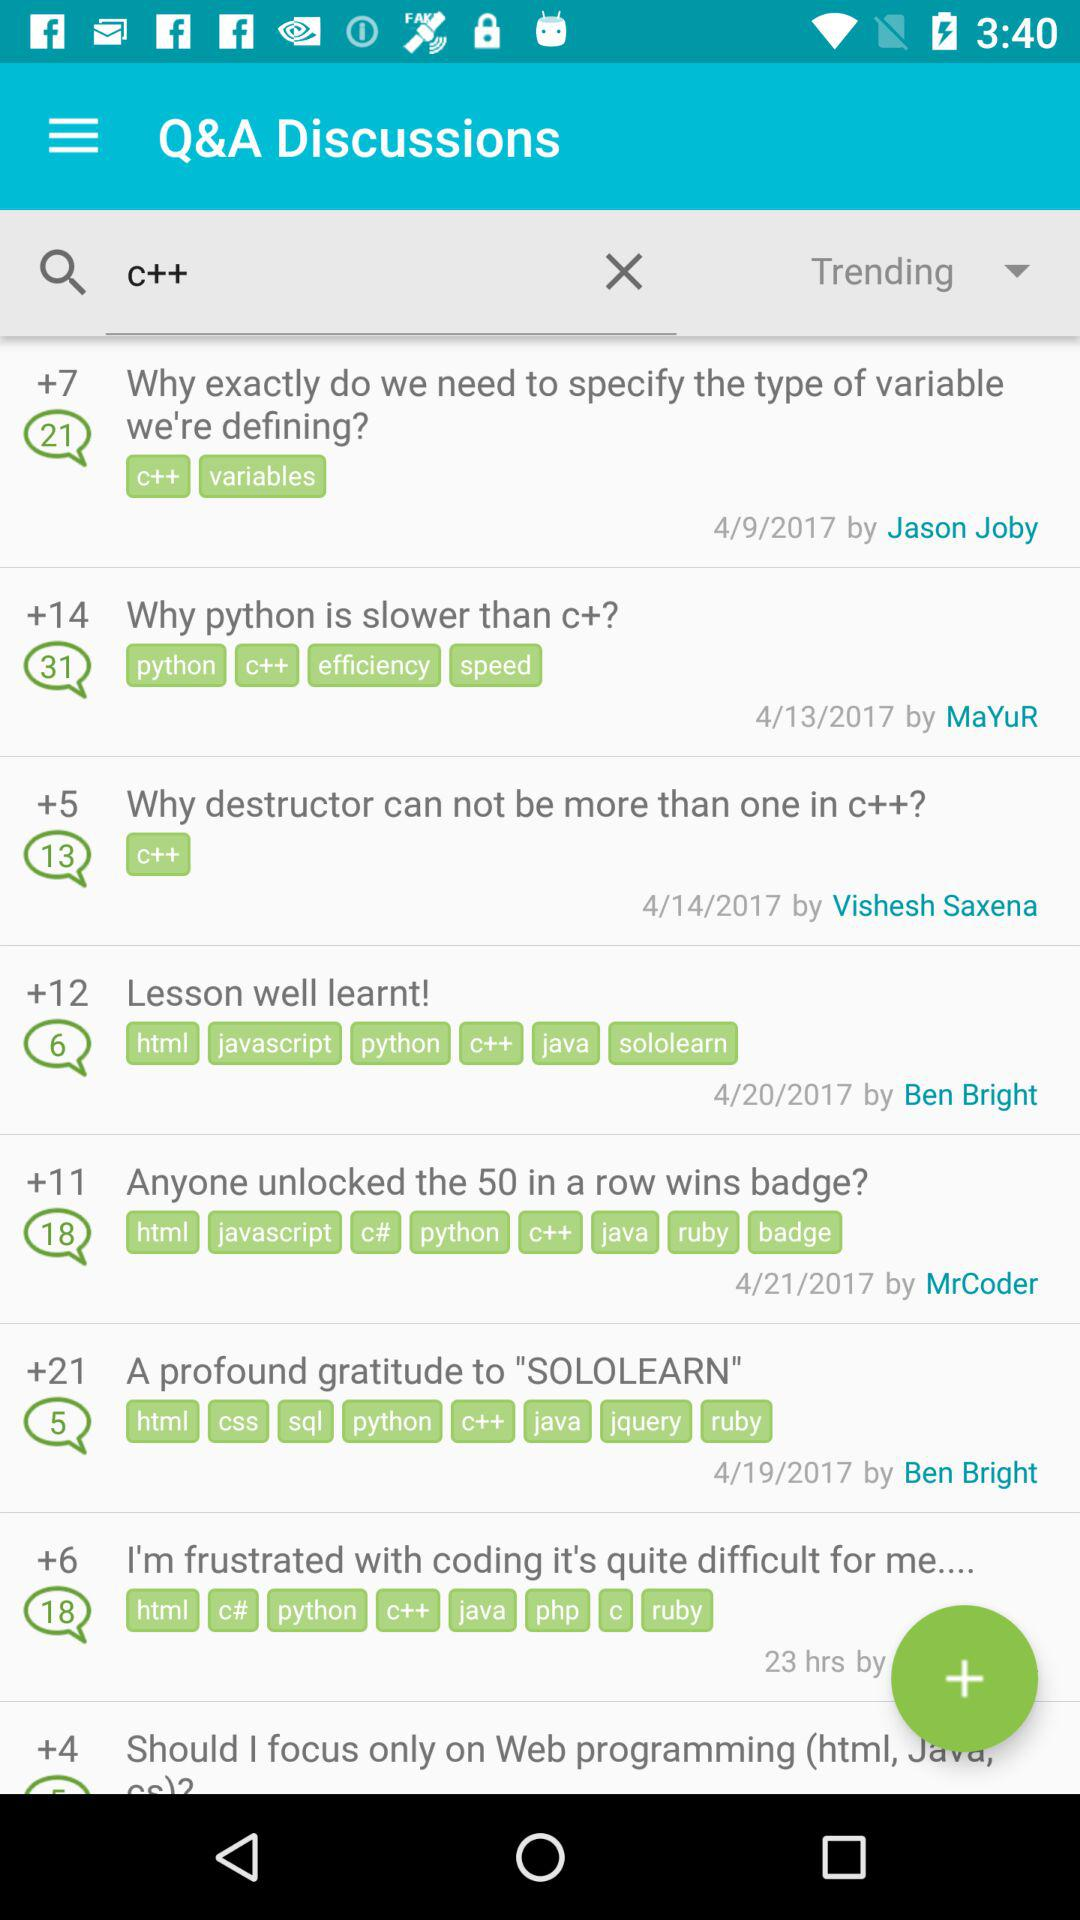How many votes were given by Ben Bright?
When the provided information is insufficient, respond with <no answer>. <no answer> 